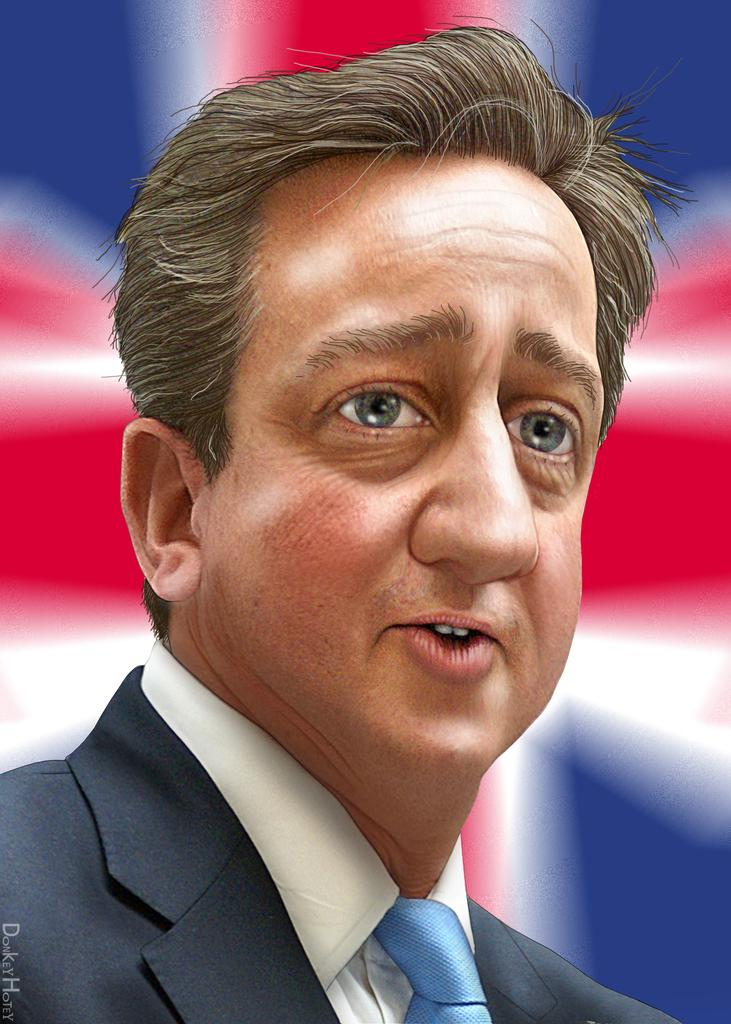What type of image is being described? The image is animated. Can you describe the person in the image? The person in the image is wearing a blazer, a shirt, and a tie. What is the background of the image like? The background of the image is blurred. Is there any additional information about the image? Yes, there is a watermark at the left bottom of the image. What color are the trousers the person is wearing in the image? The provided facts do not mention the color or presence of trousers on the person in the image. Can you tell me how the person's mom is involved in the image? There is no mention of the person's mom or any other family members in the image or the provided facts. 